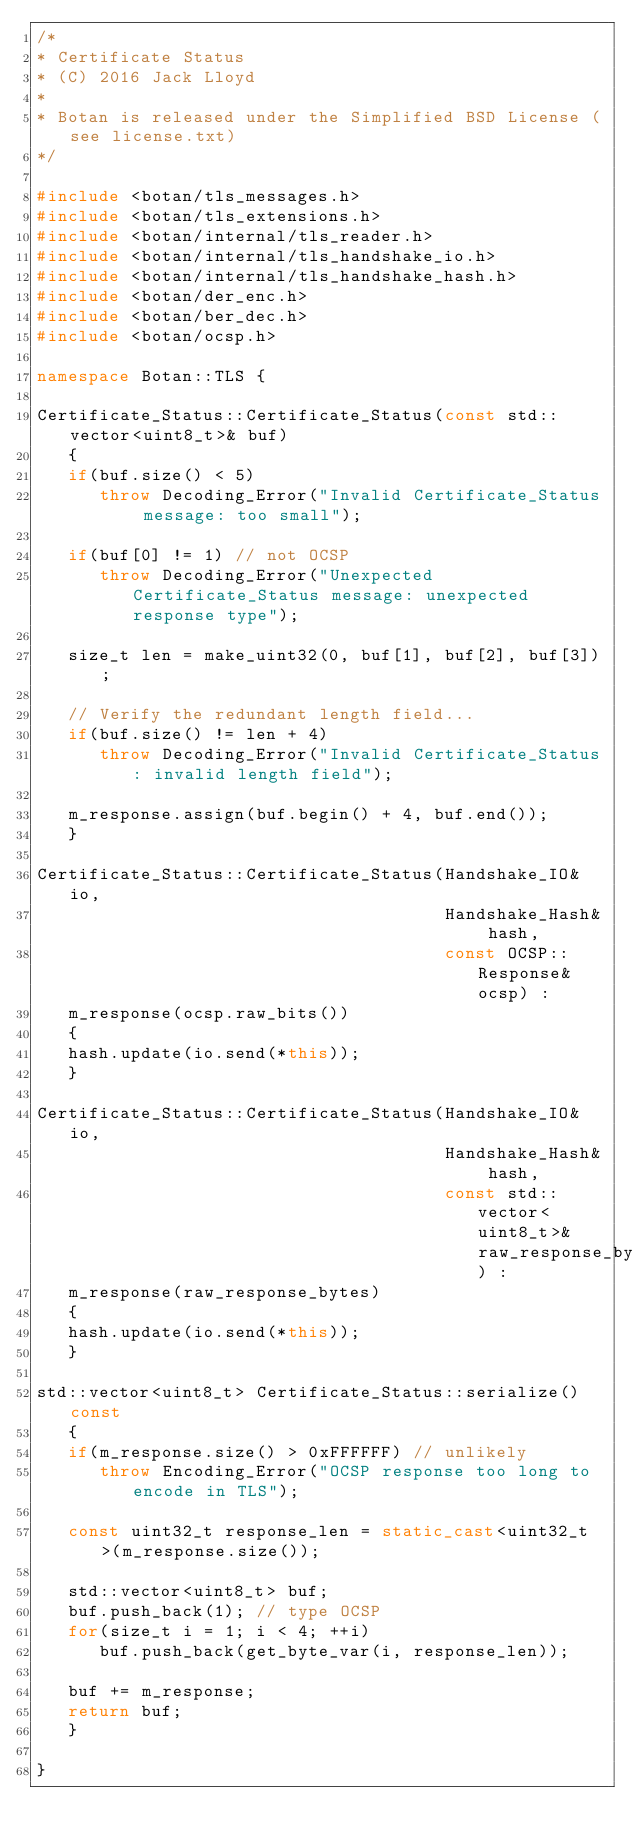Convert code to text. <code><loc_0><loc_0><loc_500><loc_500><_C++_>/*
* Certificate Status
* (C) 2016 Jack Lloyd
*
* Botan is released under the Simplified BSD License (see license.txt)
*/

#include <botan/tls_messages.h>
#include <botan/tls_extensions.h>
#include <botan/internal/tls_reader.h>
#include <botan/internal/tls_handshake_io.h>
#include <botan/internal/tls_handshake_hash.h>
#include <botan/der_enc.h>
#include <botan/ber_dec.h>
#include <botan/ocsp.h>

namespace Botan::TLS {

Certificate_Status::Certificate_Status(const std::vector<uint8_t>& buf)
   {
   if(buf.size() < 5)
      throw Decoding_Error("Invalid Certificate_Status message: too small");

   if(buf[0] != 1) // not OCSP
      throw Decoding_Error("Unexpected Certificate_Status message: unexpected response type");

   size_t len = make_uint32(0, buf[1], buf[2], buf[3]);

   // Verify the redundant length field...
   if(buf.size() != len + 4)
      throw Decoding_Error("Invalid Certificate_Status: invalid length field");

   m_response.assign(buf.begin() + 4, buf.end());
   }

Certificate_Status::Certificate_Status(Handshake_IO& io,
                                       Handshake_Hash& hash,
                                       const OCSP::Response& ocsp) :
   m_response(ocsp.raw_bits())
   {
   hash.update(io.send(*this));
   }

Certificate_Status::Certificate_Status(Handshake_IO& io,
                                       Handshake_Hash& hash,
                                       const std::vector<uint8_t>& raw_response_bytes) :
   m_response(raw_response_bytes)
   {
   hash.update(io.send(*this));
   }

std::vector<uint8_t> Certificate_Status::serialize() const
   {
   if(m_response.size() > 0xFFFFFF) // unlikely
      throw Encoding_Error("OCSP response too long to encode in TLS");

   const uint32_t response_len = static_cast<uint32_t>(m_response.size());

   std::vector<uint8_t> buf;
   buf.push_back(1); // type OCSP
   for(size_t i = 1; i < 4; ++i)
      buf.push_back(get_byte_var(i, response_len));

   buf += m_response;
   return buf;
   }

}
</code> 